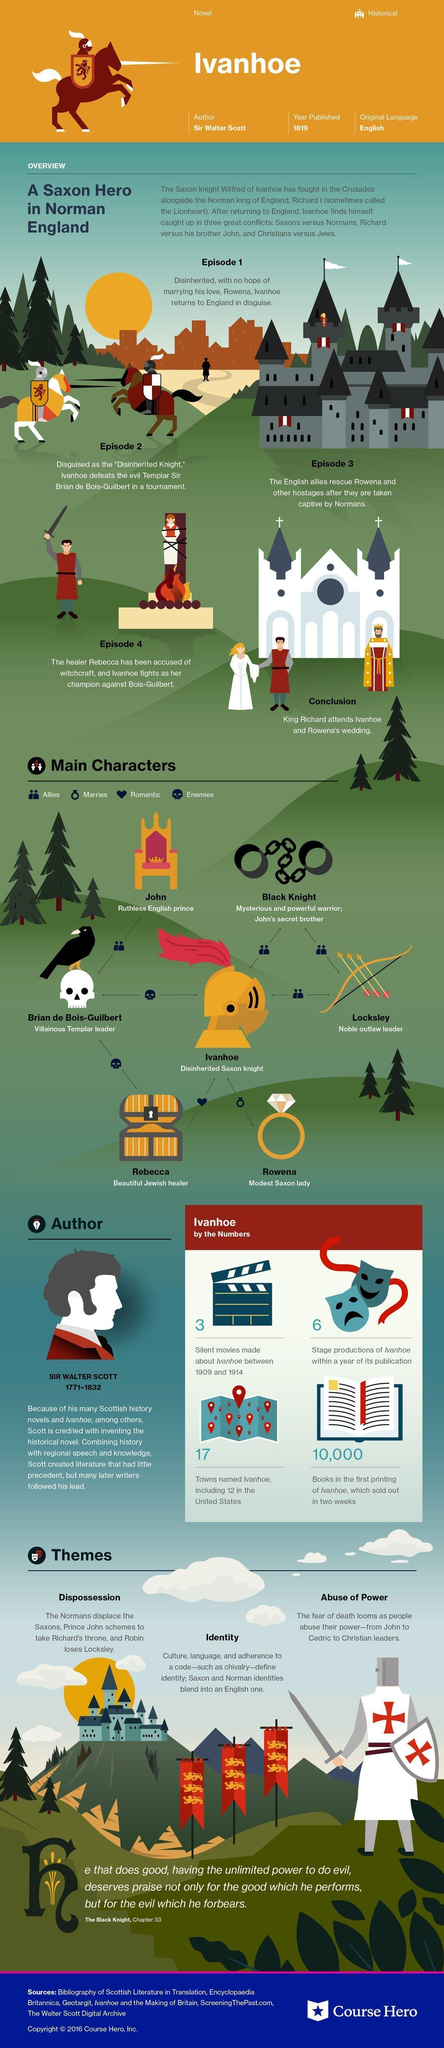How many films made with no sound based on the novel Ivanhoe?
Answer the question with a short phrase. 3 When did the creator of "Ivanhoe" died? 1832 What is the name of the hard English Prince? John How many Allies are there for Black Knight? 2 Who is the opposition of Ivanhoe? Brian de Bois-Guilbert In which episode Ivanhoe wins the fight against Brian? 2 Who are the allies of John? Brian de Bois-Guilbert How many cities are named after "Ivanhoe" excluding 12 in United States? 5 Who is the wife of Ivanhoe? Rowena Who are the allies of Ivanhoe? Black Knight, Locksley 